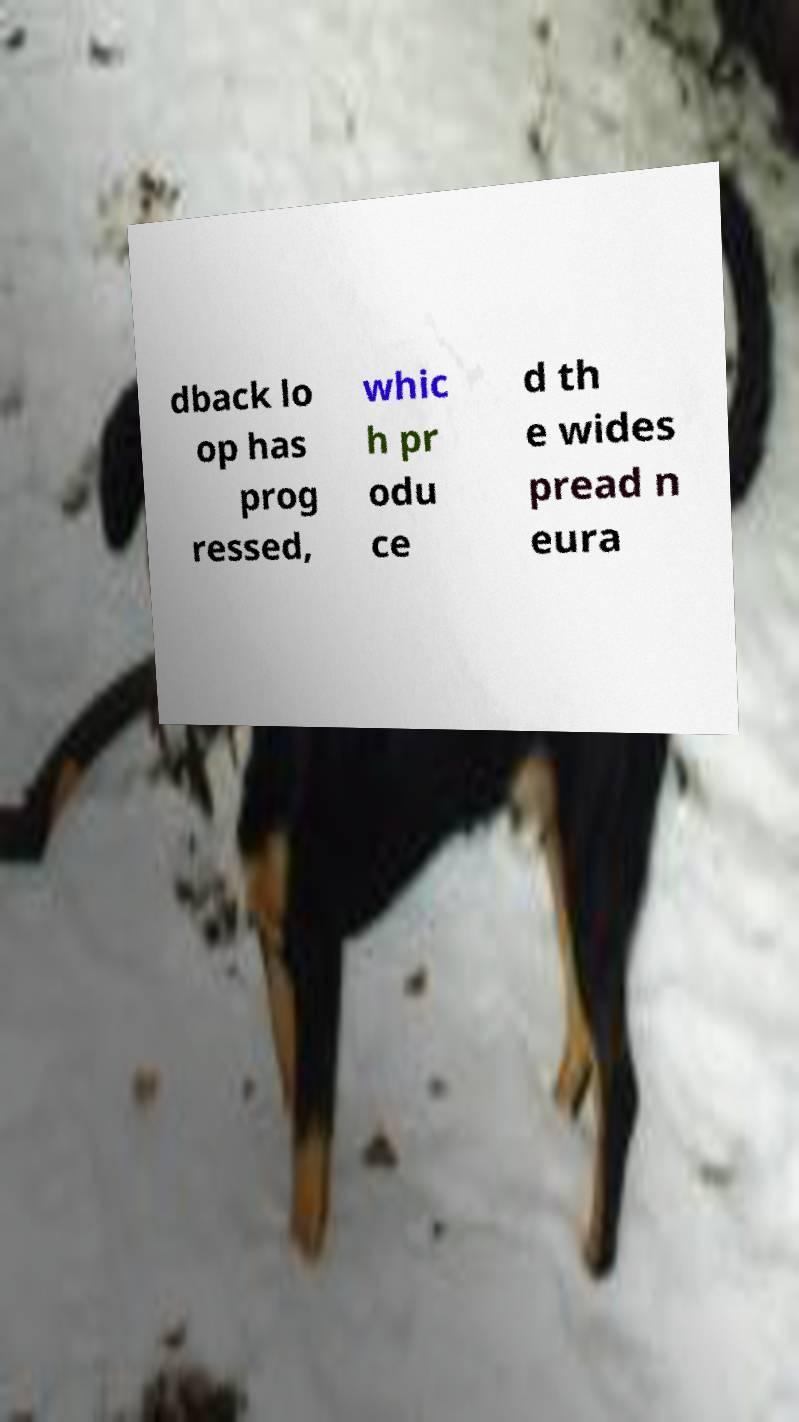What messages or text are displayed in this image? I need them in a readable, typed format. dback lo op has prog ressed, whic h pr odu ce d th e wides pread n eura 